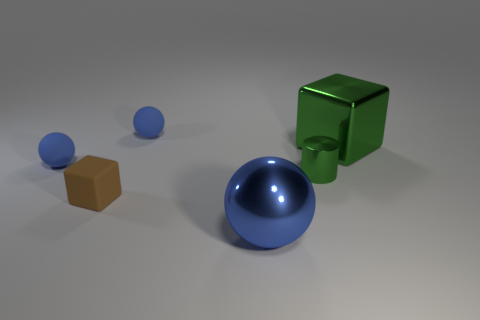Add 3 rubber objects. How many objects exist? 9 Subtract all blocks. How many objects are left? 4 Add 5 tiny green shiny objects. How many tiny green shiny objects exist? 6 Subtract 0 yellow balls. How many objects are left? 6 Subtract all tiny metallic objects. Subtract all green metal blocks. How many objects are left? 4 Add 5 green cylinders. How many green cylinders are left? 6 